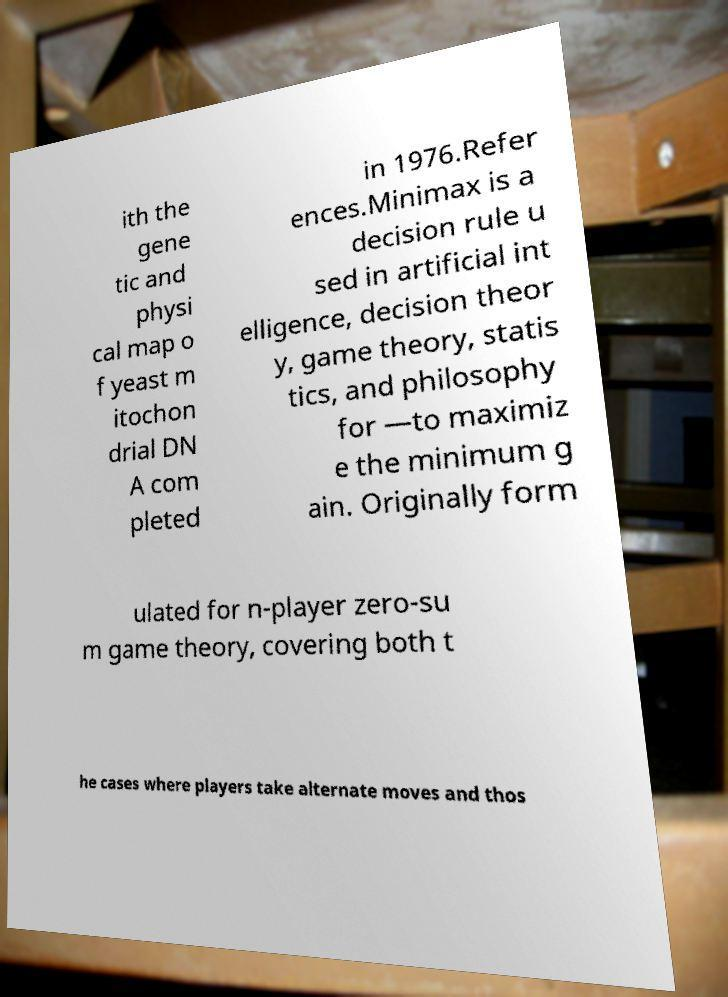Can you accurately transcribe the text from the provided image for me? ith the gene tic and physi cal map o f yeast m itochon drial DN A com pleted in 1976.Refer ences.Minimax is a decision rule u sed in artificial int elligence, decision theor y, game theory, statis tics, and philosophy for —to maximiz e the minimum g ain. Originally form ulated for n-player zero-su m game theory, covering both t he cases where players take alternate moves and thos 